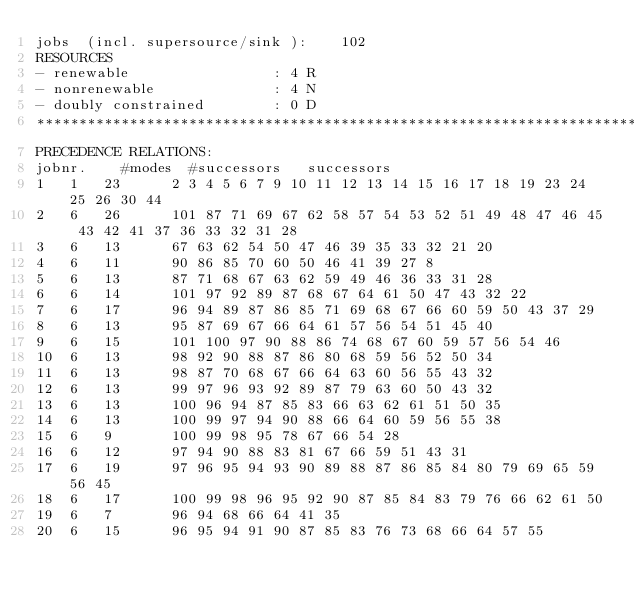<code> <loc_0><loc_0><loc_500><loc_500><_ObjectiveC_>jobs  (incl. supersource/sink ):	102
RESOURCES
- renewable                 : 4 R
- nonrenewable              : 4 N
- doubly constrained        : 0 D
************************************************************************
PRECEDENCE RELATIONS:
jobnr.    #modes  #successors   successors
1	1	23		2 3 4 5 6 7 9 10 11 12 13 14 15 16 17 18 19 23 24 25 26 30 44 
2	6	26		101 87 71 69 67 62 58 57 54 53 52 51 49 48 47 46 45 43 42 41 37 36 33 32 31 28 
3	6	13		67 63 62 54 50 47 46 39 35 33 32 21 20 
4	6	11		90 86 85 70 60 50 46 41 39 27 8 
5	6	13		87 71 68 67 63 62 59 49 46 36 33 31 28 
6	6	14		101 97 92 89 87 68 67 64 61 50 47 43 32 22 
7	6	17		96 94 89 87 86 85 71 69 68 67 66 60 59 50 43 37 29 
8	6	13		95 87 69 67 66 64 61 57 56 54 51 45 40 
9	6	15		101 100 97 90 88 86 74 68 67 60 59 57 56 54 46 
10	6	13		98 92 90 88 87 86 80 68 59 56 52 50 34 
11	6	13		98 87 70 68 67 66 64 63 60 56 55 43 32 
12	6	13		99 97 96 93 92 89 87 79 63 60 50 43 32 
13	6	13		100 96 94 87 85 83 66 63 62 61 51 50 35 
14	6	13		100 99 97 94 90 88 66 64 60 59 56 55 38 
15	6	9		100 99 98 95 78 67 66 54 28 
16	6	12		97 94 90 88 83 81 67 66 59 51 43 31 
17	6	19		97 96 95 94 93 90 89 88 87 86 85 84 80 79 69 65 59 56 45 
18	6	17		100 99 98 96 95 92 90 87 85 84 83 79 76 66 62 61 50 
19	6	7		96 94 68 66 64 41 35 
20	6	15		96 95 94 91 90 87 85 83 76 73 68 66 64 57 55 </code> 